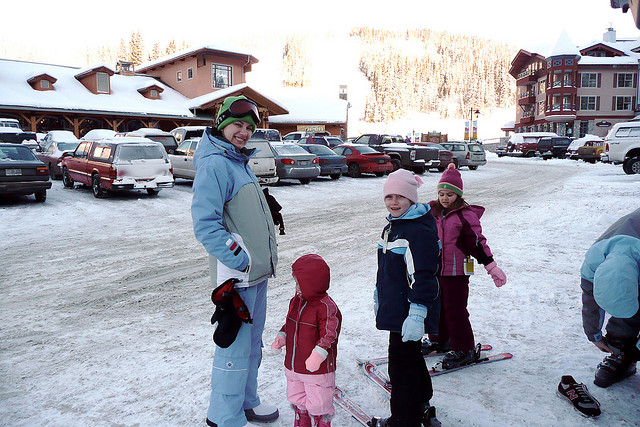Identify the text displayed in this image. z 